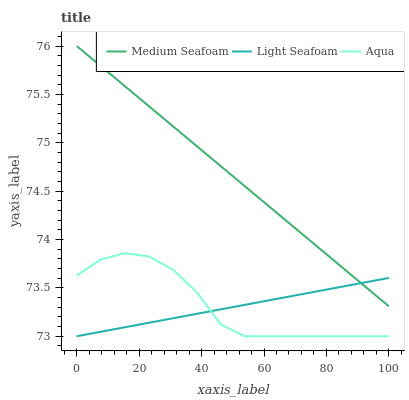Does Light Seafoam have the minimum area under the curve?
Answer yes or no. Yes. Does Medium Seafoam have the maximum area under the curve?
Answer yes or no. Yes. Does Aqua have the minimum area under the curve?
Answer yes or no. No. Does Aqua have the maximum area under the curve?
Answer yes or no. No. Is Medium Seafoam the smoothest?
Answer yes or no. Yes. Is Aqua the roughest?
Answer yes or no. Yes. Is Aqua the smoothest?
Answer yes or no. No. Is Medium Seafoam the roughest?
Answer yes or no. No. Does Light Seafoam have the lowest value?
Answer yes or no. Yes. Does Medium Seafoam have the lowest value?
Answer yes or no. No. Does Medium Seafoam have the highest value?
Answer yes or no. Yes. Does Aqua have the highest value?
Answer yes or no. No. Is Aqua less than Medium Seafoam?
Answer yes or no. Yes. Is Medium Seafoam greater than Aqua?
Answer yes or no. Yes. Does Light Seafoam intersect Medium Seafoam?
Answer yes or no. Yes. Is Light Seafoam less than Medium Seafoam?
Answer yes or no. No. Is Light Seafoam greater than Medium Seafoam?
Answer yes or no. No. Does Aqua intersect Medium Seafoam?
Answer yes or no. No. 